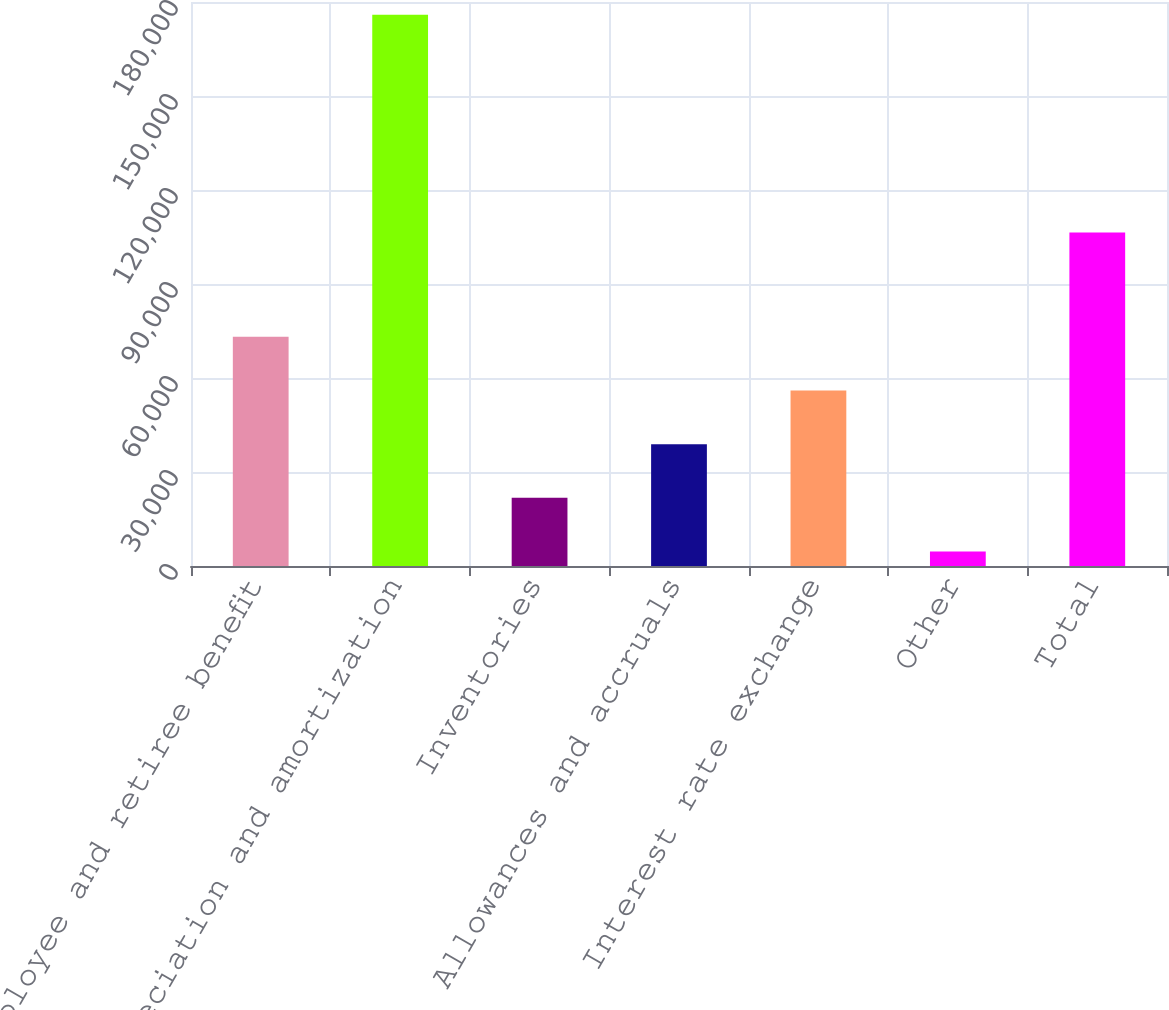Convert chart. <chart><loc_0><loc_0><loc_500><loc_500><bar_chart><fcel>Employee and retiree benefit<fcel>Depreciation and amortization<fcel>Inventories<fcel>Allowances and accruals<fcel>Interest rate exchange<fcel>Other<fcel>Total<nl><fcel>73139.2<fcel>175894<fcel>21761.8<fcel>38887.6<fcel>56013.4<fcel>4636<fcel>106473<nl></chart> 